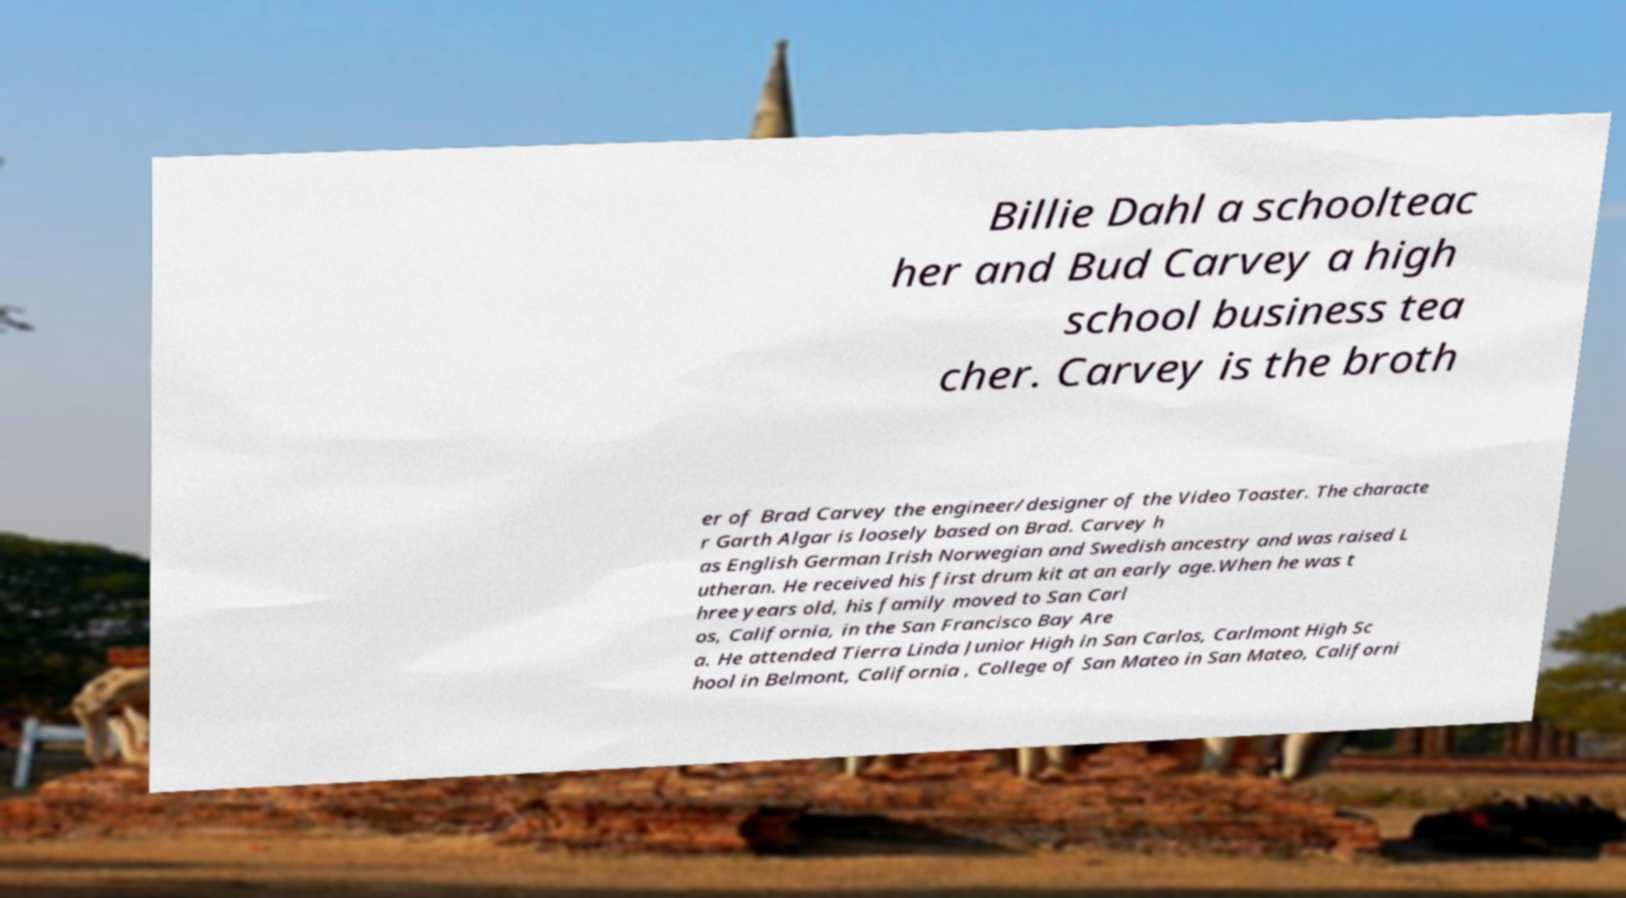Please identify and transcribe the text found in this image. Billie Dahl a schoolteac her and Bud Carvey a high school business tea cher. Carvey is the broth er of Brad Carvey the engineer/designer of the Video Toaster. The characte r Garth Algar is loosely based on Brad. Carvey h as English German Irish Norwegian and Swedish ancestry and was raised L utheran. He received his first drum kit at an early age.When he was t hree years old, his family moved to San Carl os, California, in the San Francisco Bay Are a. He attended Tierra Linda Junior High in San Carlos, Carlmont High Sc hool in Belmont, California , College of San Mateo in San Mateo, Californi 